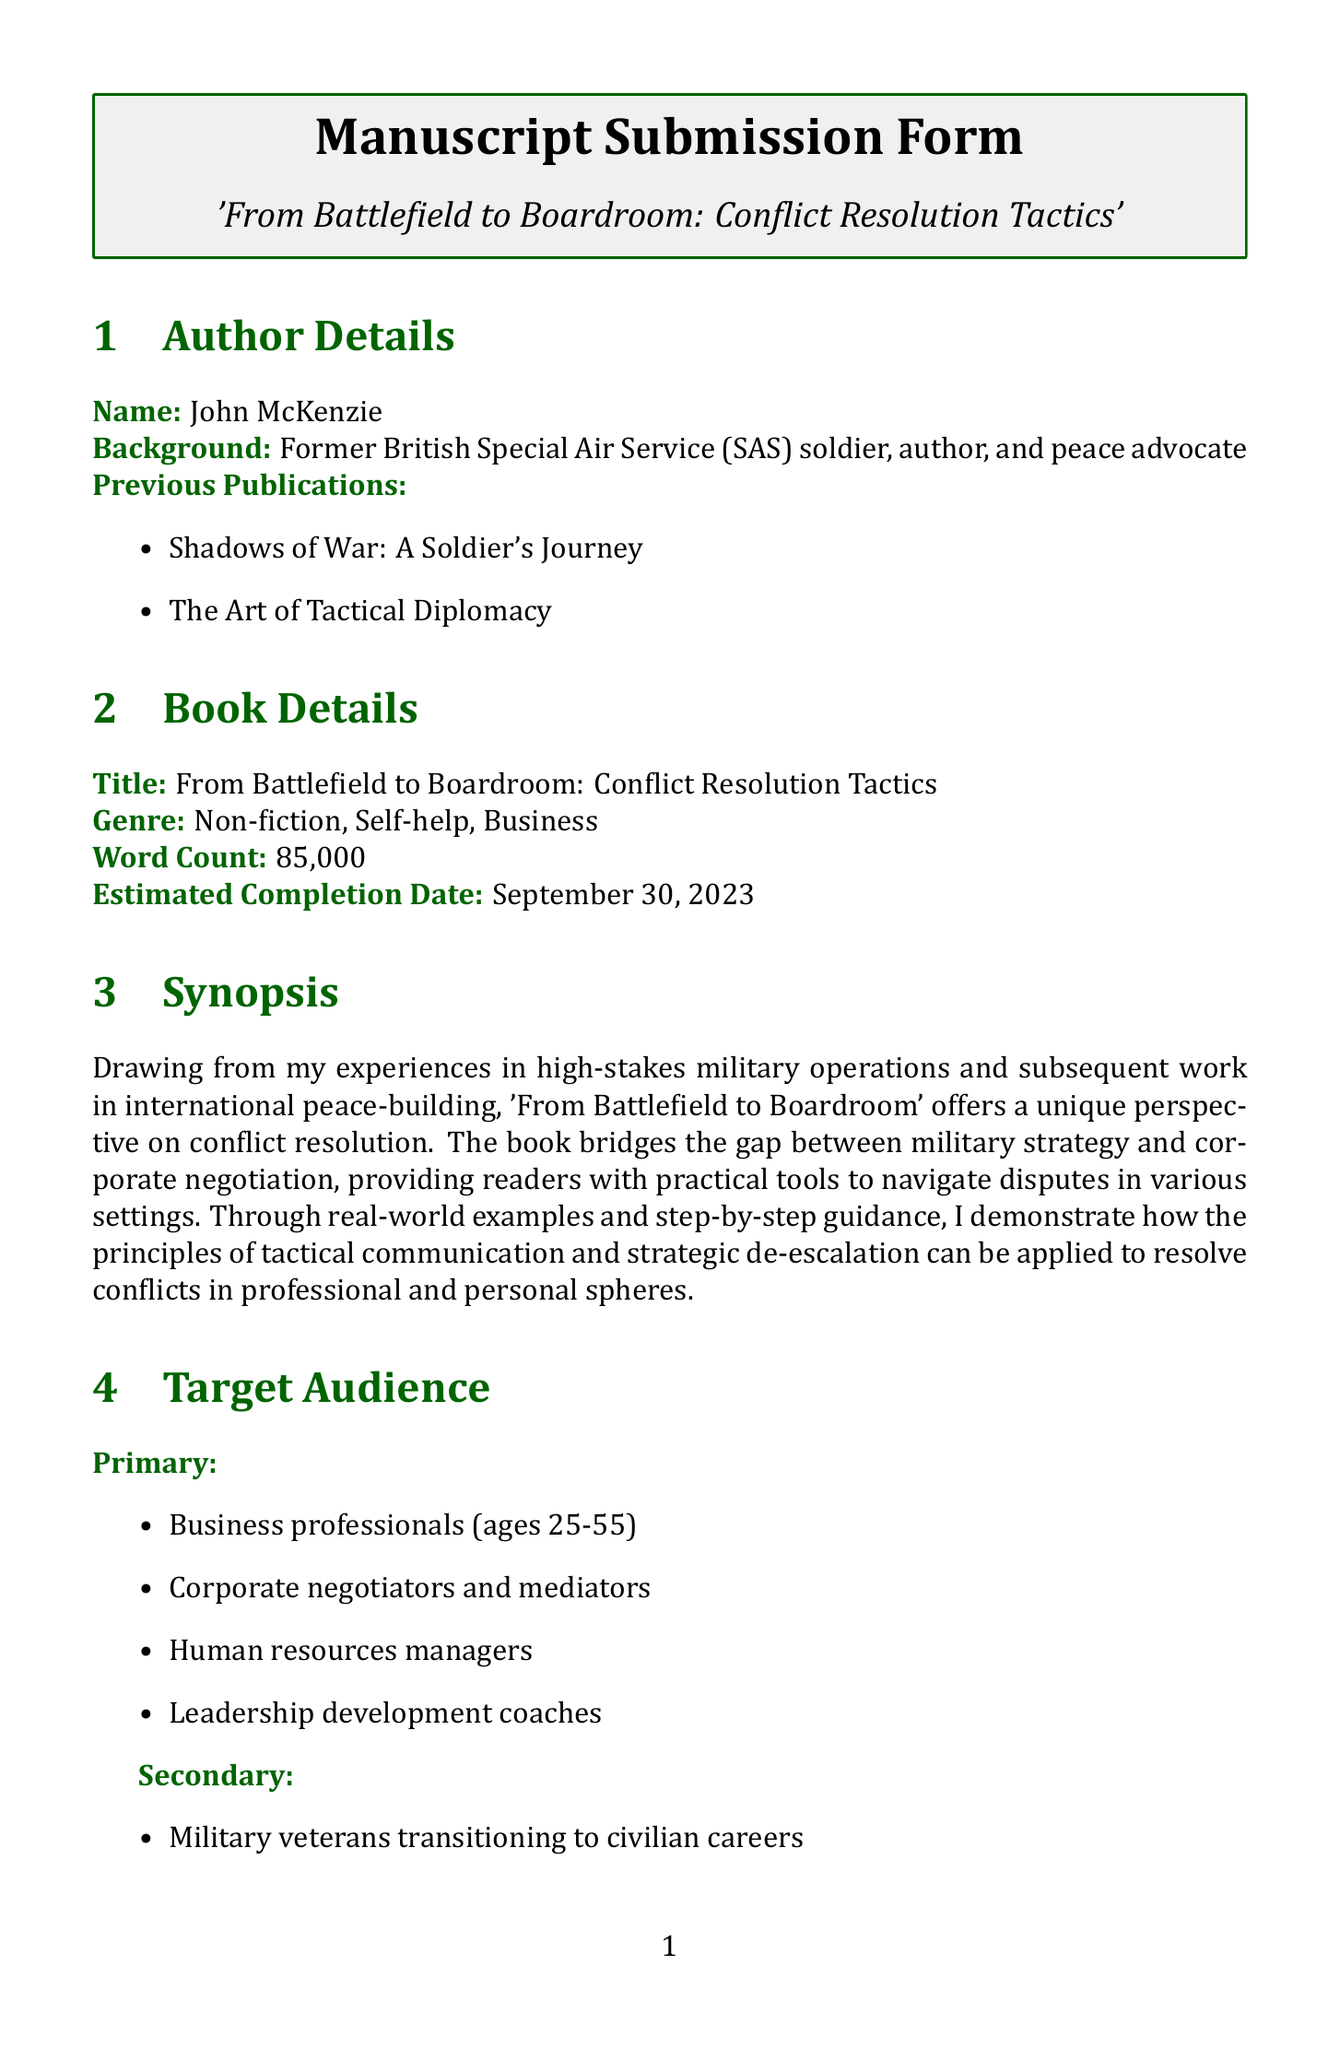What is the title of the book? The title is explicitly stated in the document under book details.
Answer: From Battlefield to Boardroom: Conflict Resolution Tactics Who is the author of the manuscript? The author's name is given in the author details section of the document.
Answer: John McKenzie What is the estimated completion date of the book? This date is listed in the book details section.
Answer: September 30, 2023 What is the primary demographic age range for the target audience? The demographic details mention the age range of the target audience.
Answer: 25-65 Which publisher is preferred for the manuscript? The preferred publishers are listed in the publishing preferences section.
Answer: Penguin Random House What is a unique selling point of this book? The unique selling points are mentioned under marketing potential.
Answer: Author's rare combination of military and peace-building experience Name one comparable title mentioned in the document. The comparable titles are listed under comparable titles section.
Answer: Getting to Yes by Roger Fisher and William Ury What is one of the additional materials required for submission? The submission requirements section specifies the additional materials needed.
Answer: Author photo (high-resolution) 